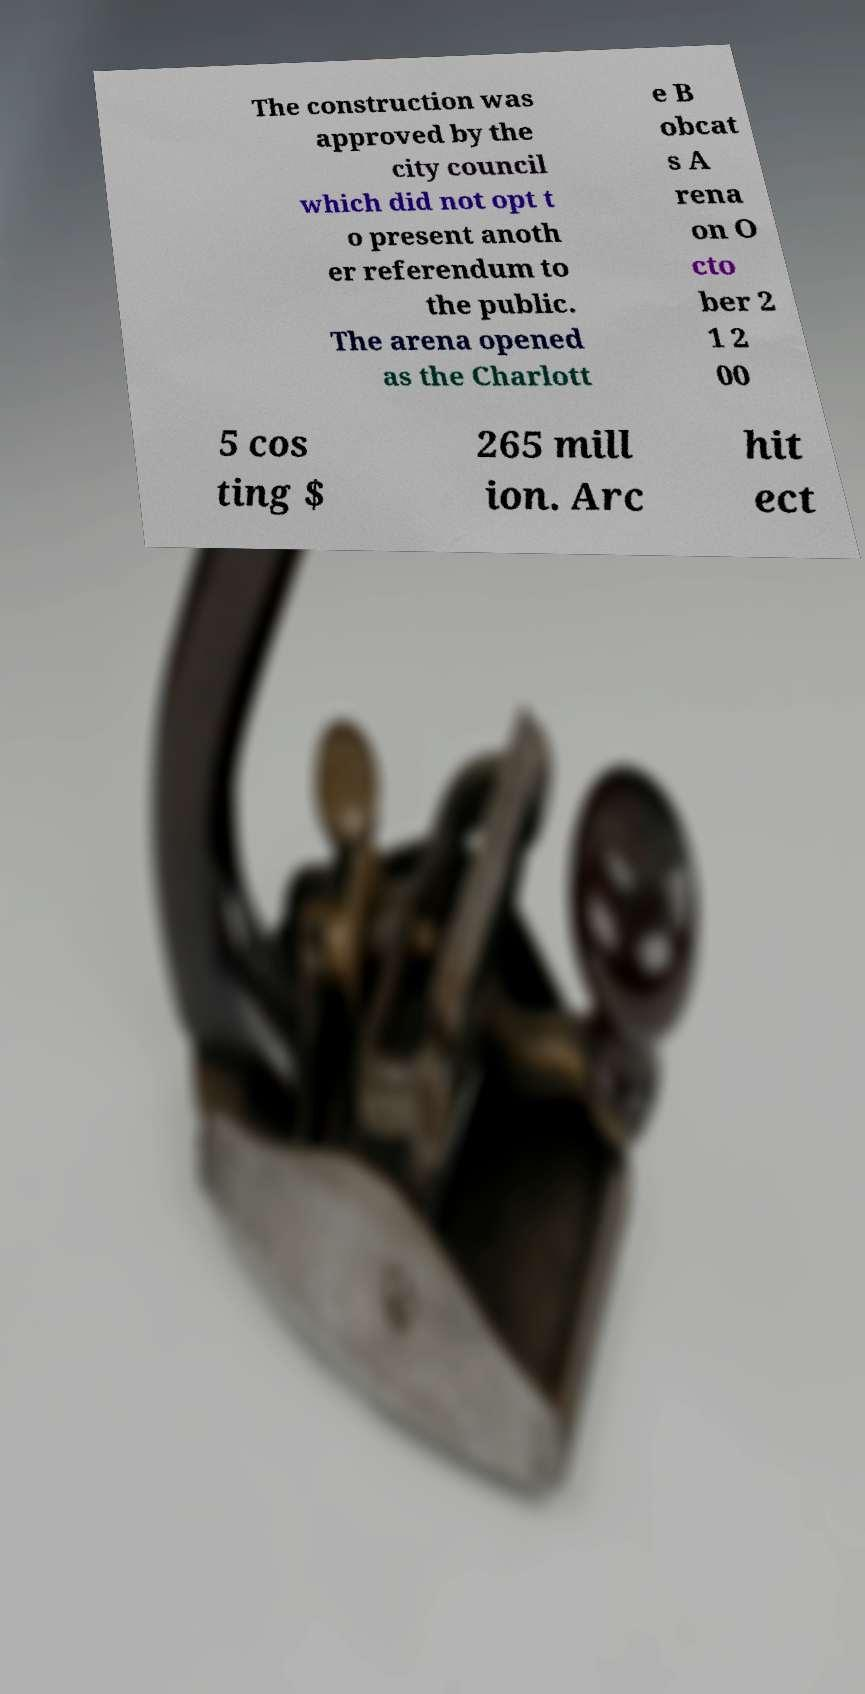Can you accurately transcribe the text from the provided image for me? The construction was approved by the city council which did not opt t o present anoth er referendum to the public. The arena opened as the Charlott e B obcat s A rena on O cto ber 2 1 2 00 5 cos ting $ 265 mill ion. Arc hit ect 